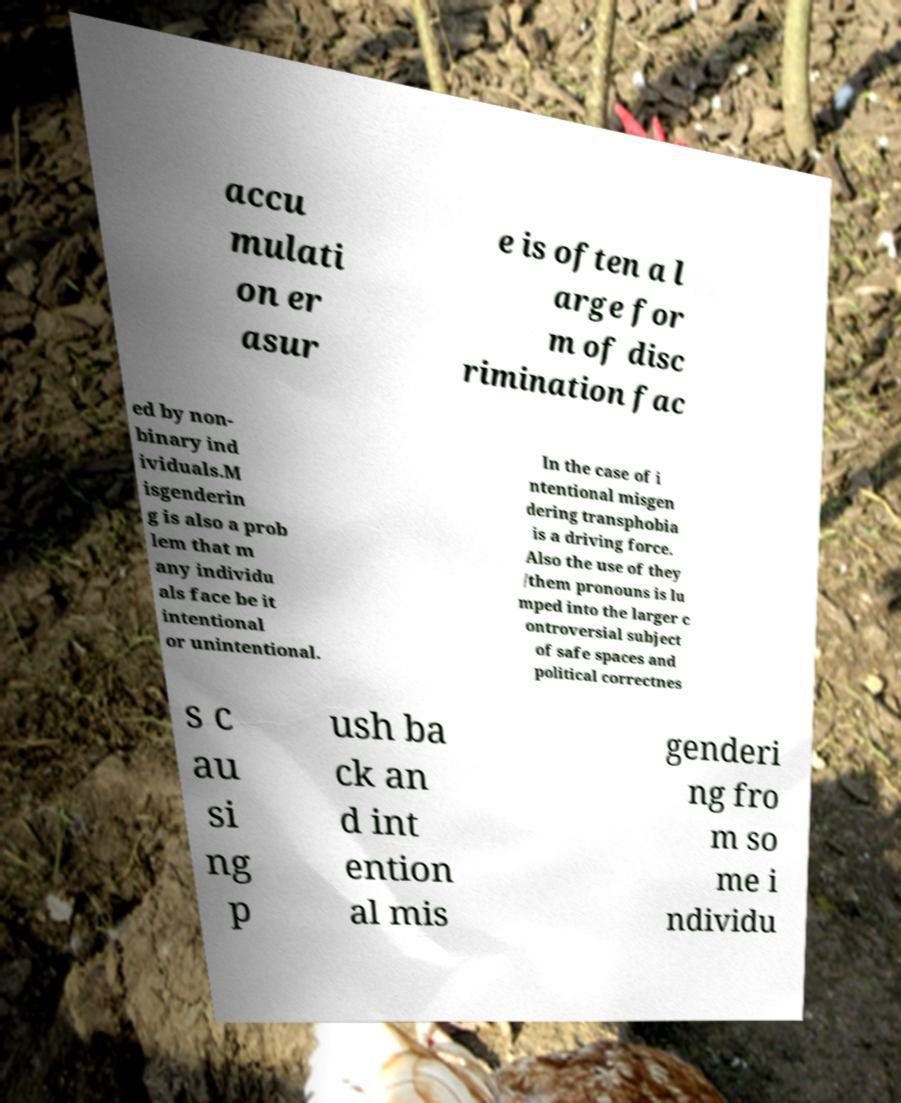There's text embedded in this image that I need extracted. Can you transcribe it verbatim? accu mulati on er asur e is often a l arge for m of disc rimination fac ed by non- binary ind ividuals.M isgenderin g is also a prob lem that m any individu als face be it intentional or unintentional. In the case of i ntentional misgen dering transphobia is a driving force. Also the use of they /them pronouns is lu mped into the larger c ontroversial subject of safe spaces and political correctnes s c au si ng p ush ba ck an d int ention al mis genderi ng fro m so me i ndividu 